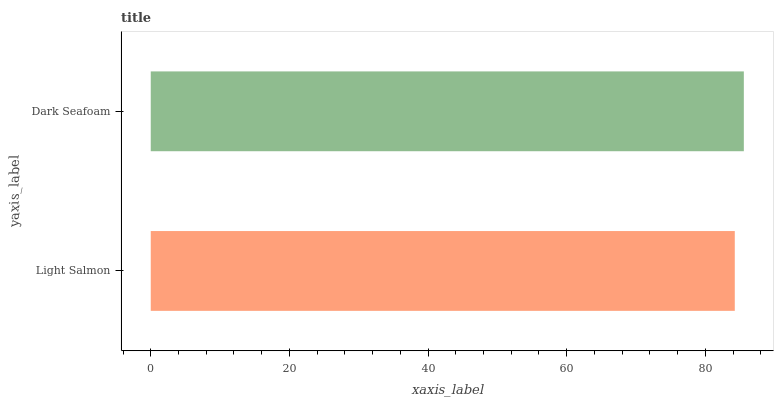Is Light Salmon the minimum?
Answer yes or no. Yes. Is Dark Seafoam the maximum?
Answer yes or no. Yes. Is Dark Seafoam the minimum?
Answer yes or no. No. Is Dark Seafoam greater than Light Salmon?
Answer yes or no. Yes. Is Light Salmon less than Dark Seafoam?
Answer yes or no. Yes. Is Light Salmon greater than Dark Seafoam?
Answer yes or no. No. Is Dark Seafoam less than Light Salmon?
Answer yes or no. No. Is Dark Seafoam the high median?
Answer yes or no. Yes. Is Light Salmon the low median?
Answer yes or no. Yes. Is Light Salmon the high median?
Answer yes or no. No. Is Dark Seafoam the low median?
Answer yes or no. No. 